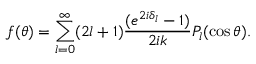<formula> <loc_0><loc_0><loc_500><loc_500>f ( \theta ) = \sum _ { l = 0 } ^ { \infty } ( 2 l + 1 ) \frac { ( e ^ { 2 i \delta _ { l } } - 1 ) } { 2 i k } P _ { l } ( \cos \theta ) .</formula> 